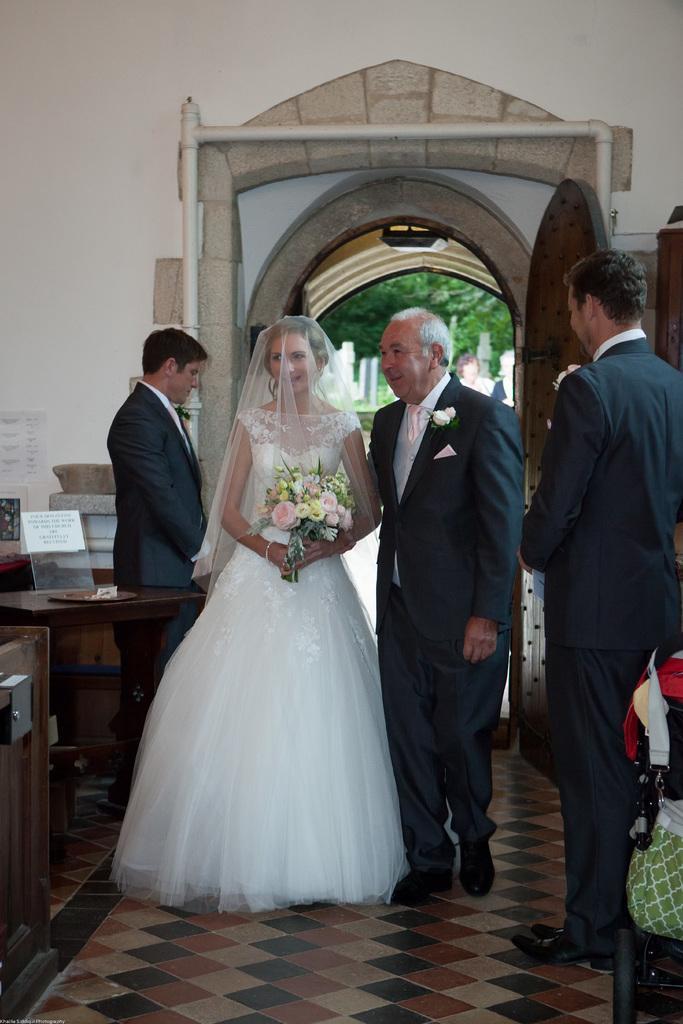Please provide a concise description of this image. In this image we can see persons on the floor. In the background we can see door and trees. On the right and left side of the image we can see tables. 